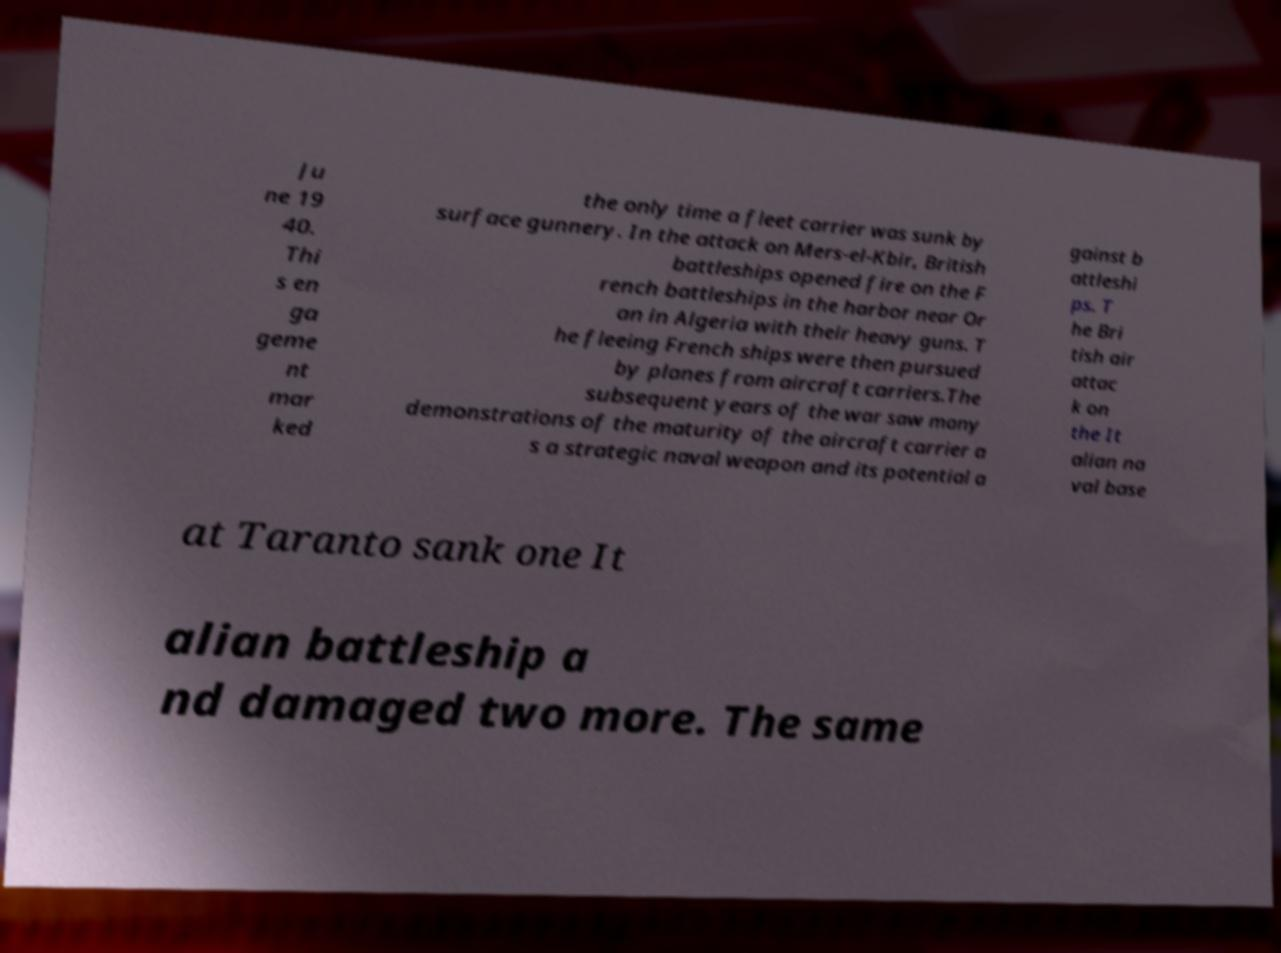Please read and relay the text visible in this image. What does it say? Ju ne 19 40. Thi s en ga geme nt mar ked the only time a fleet carrier was sunk by surface gunnery. In the attack on Mers-el-Kbir, British battleships opened fire on the F rench battleships in the harbor near Or an in Algeria with their heavy guns. T he fleeing French ships were then pursued by planes from aircraft carriers.The subsequent years of the war saw many demonstrations of the maturity of the aircraft carrier a s a strategic naval weapon and its potential a gainst b attleshi ps. T he Bri tish air attac k on the It alian na val base at Taranto sank one It alian battleship a nd damaged two more. The same 